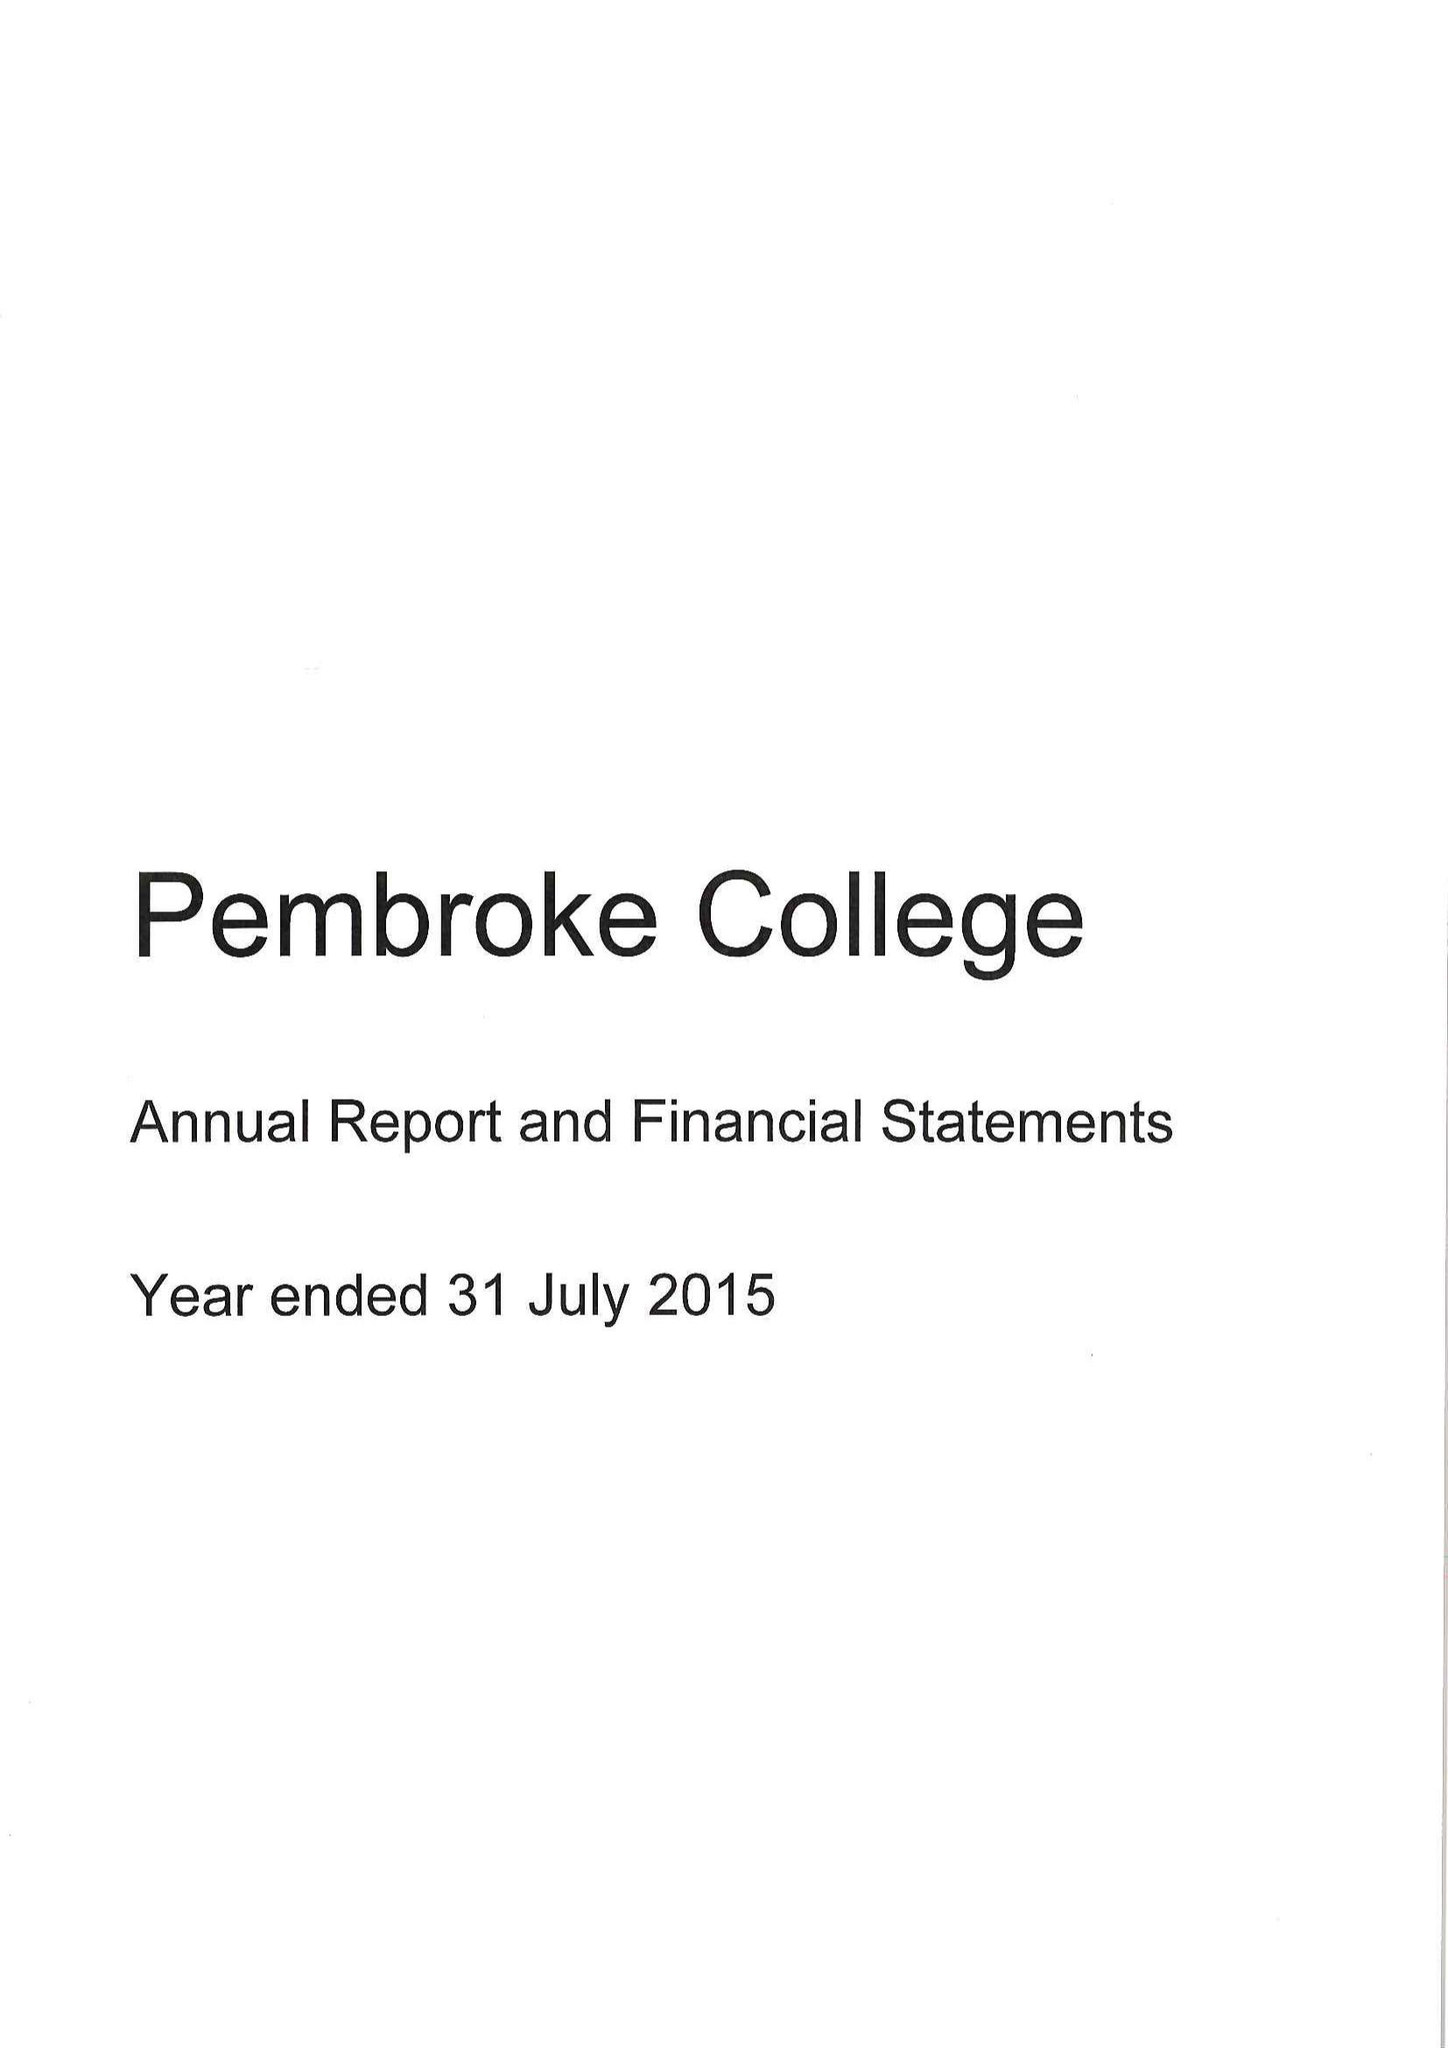What is the value for the spending_annually_in_british_pounds?
Answer the question using a single word or phrase. 10490000.00 